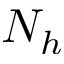<formula> <loc_0><loc_0><loc_500><loc_500>N _ { h }</formula> 